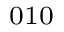<formula> <loc_0><loc_0><loc_500><loc_500>_ { 0 1 0 }</formula> 